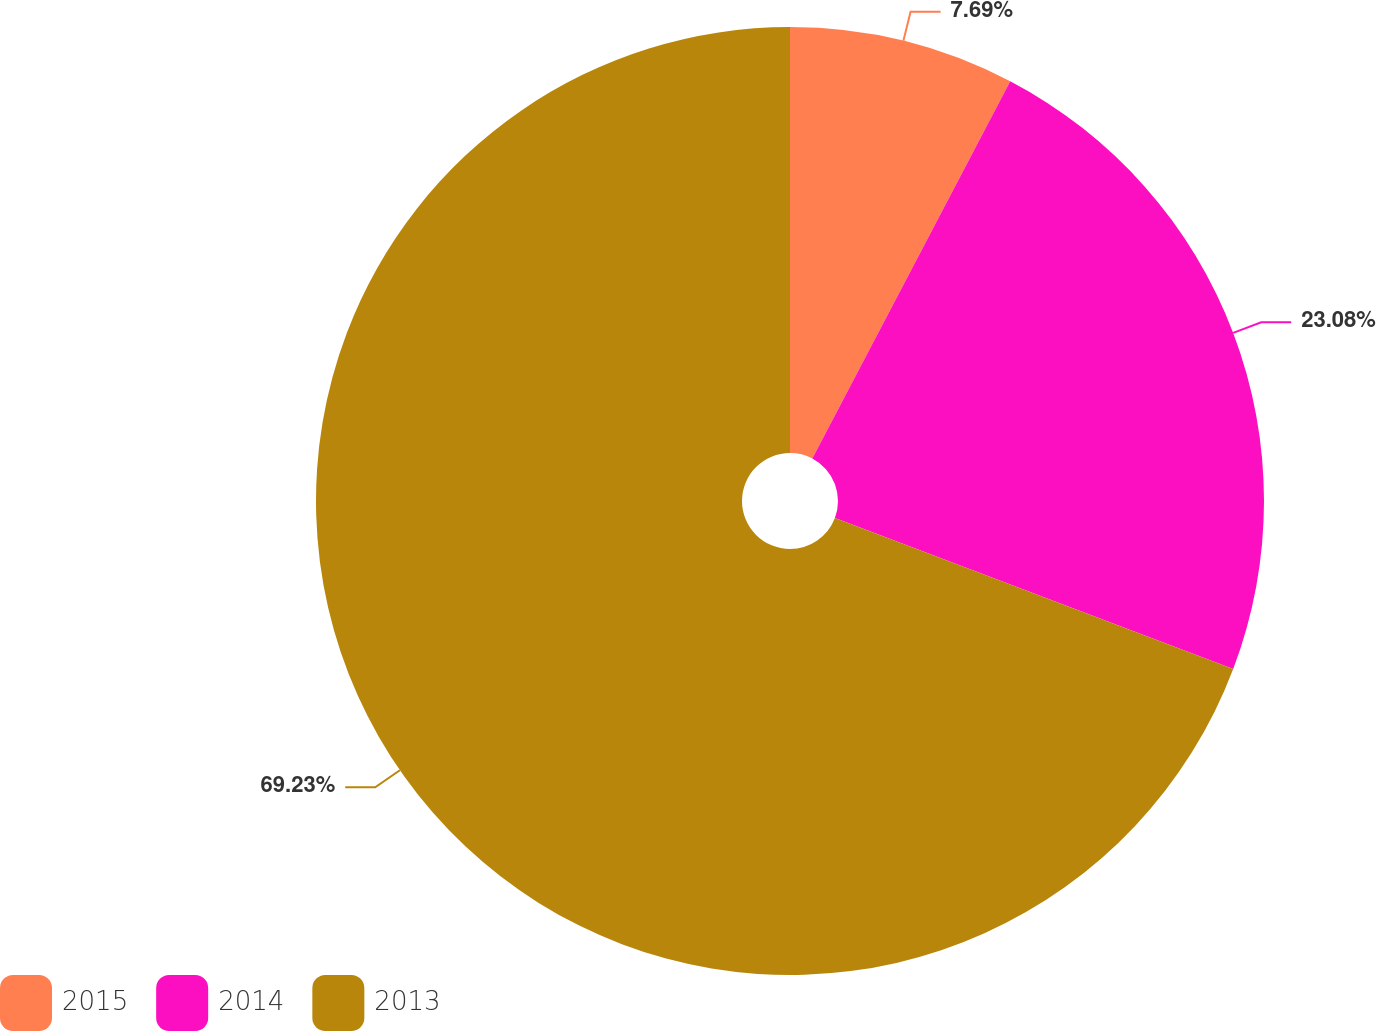Convert chart. <chart><loc_0><loc_0><loc_500><loc_500><pie_chart><fcel>2015<fcel>2014<fcel>2013<nl><fcel>7.69%<fcel>23.08%<fcel>69.23%<nl></chart> 